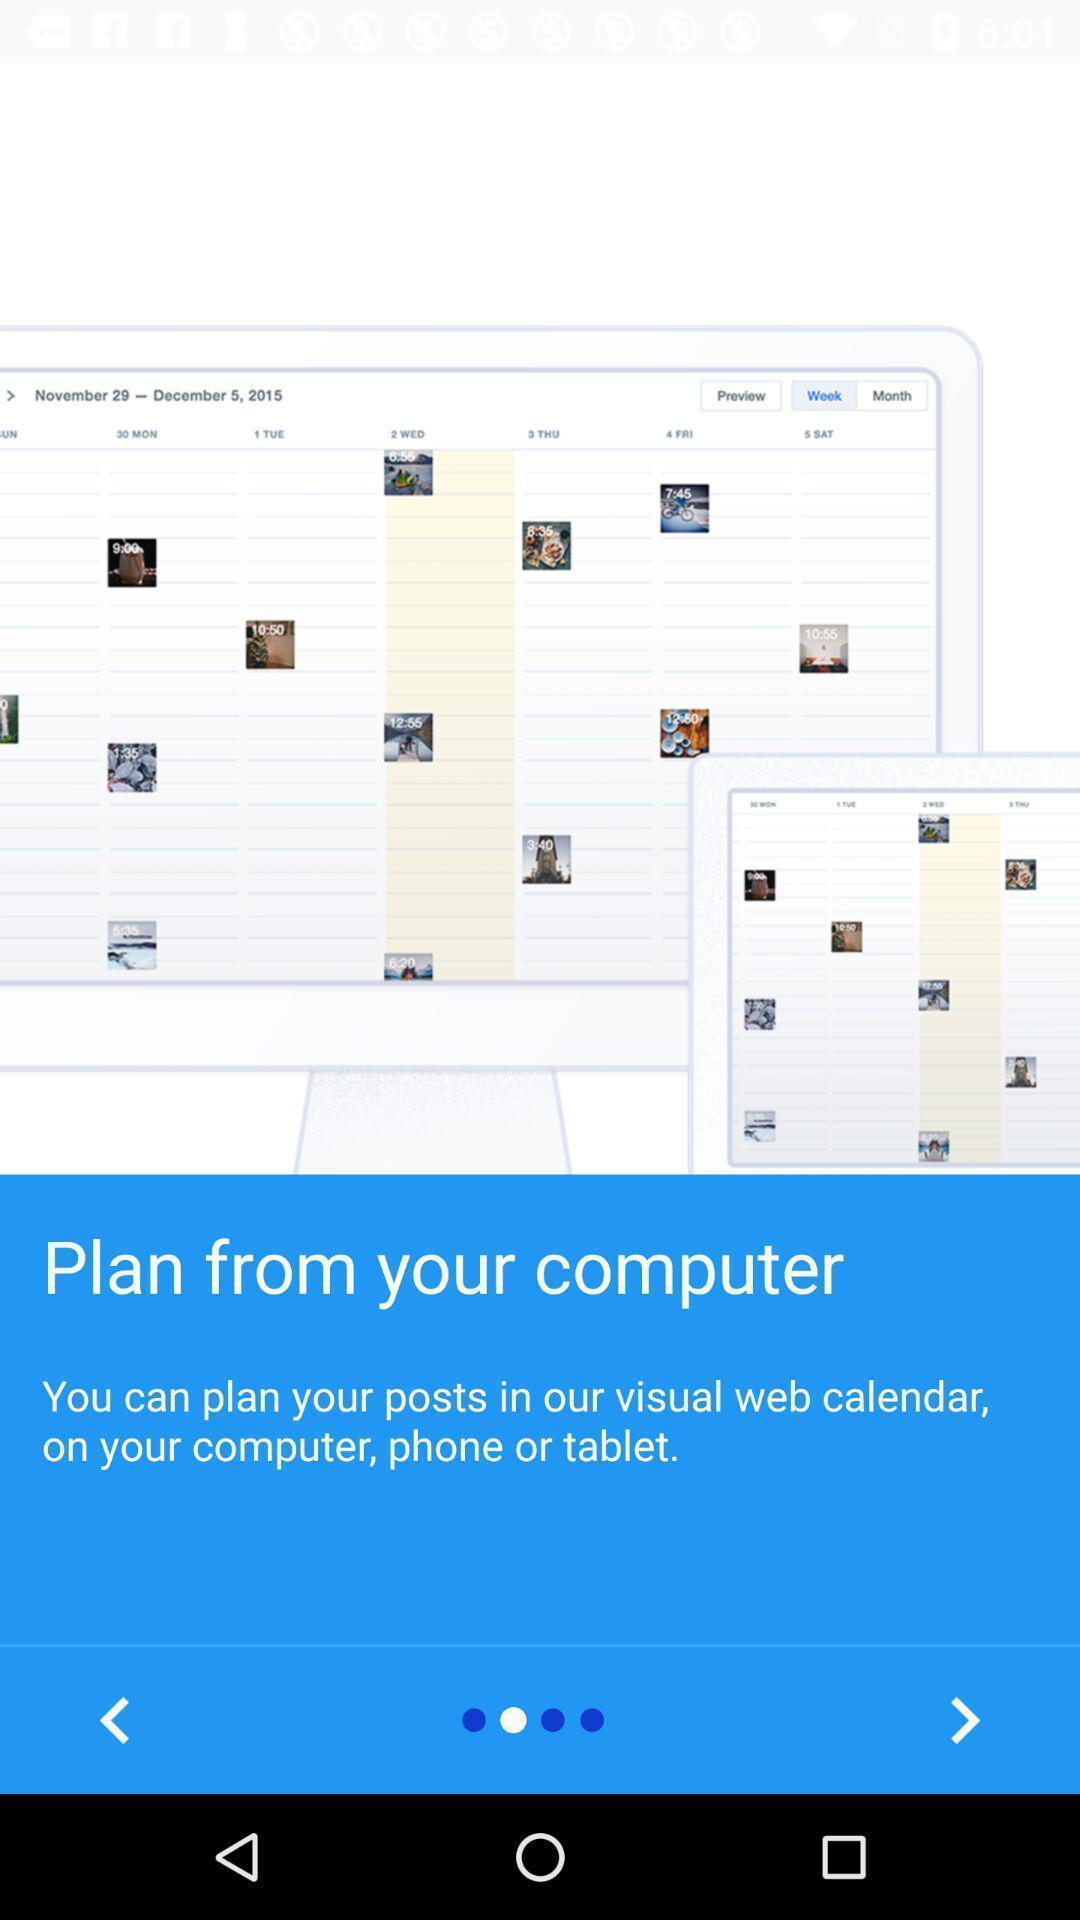Provide a detailed account of this screenshot. Welcome page for a web calendar app. 